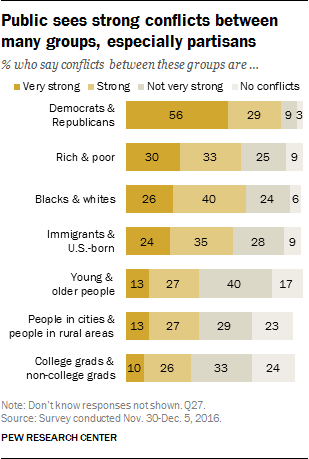Draw attention to some important aspects in this diagram. The given data indicates that the individuals belong to the category of rich and poor. The average of strong data is 31. 